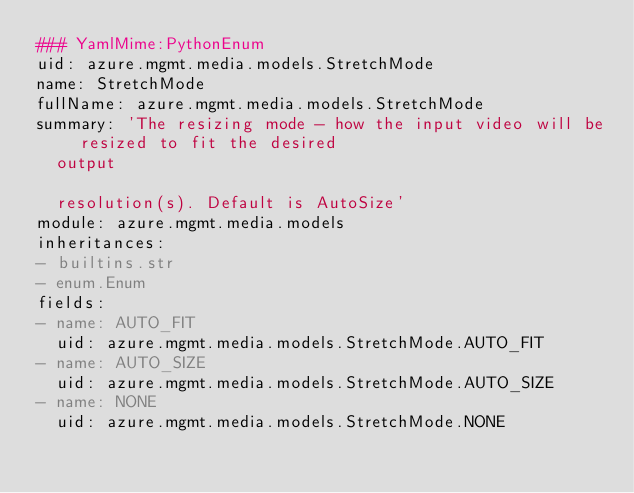<code> <loc_0><loc_0><loc_500><loc_500><_YAML_>### YamlMime:PythonEnum
uid: azure.mgmt.media.models.StretchMode
name: StretchMode
fullName: azure.mgmt.media.models.StretchMode
summary: 'The resizing mode - how the input video will be resized to fit the desired
  output

  resolution(s). Default is AutoSize'
module: azure.mgmt.media.models
inheritances:
- builtins.str
- enum.Enum
fields:
- name: AUTO_FIT
  uid: azure.mgmt.media.models.StretchMode.AUTO_FIT
- name: AUTO_SIZE
  uid: azure.mgmt.media.models.StretchMode.AUTO_SIZE
- name: NONE
  uid: azure.mgmt.media.models.StretchMode.NONE
</code> 